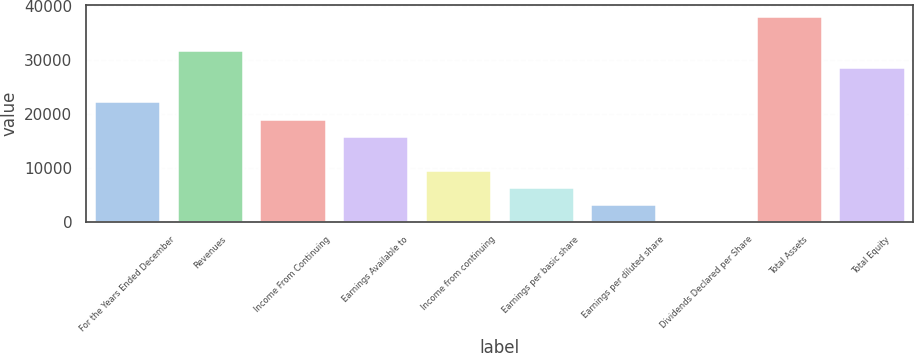Convert chart. <chart><loc_0><loc_0><loc_500><loc_500><bar_chart><fcel>For the Years Ended December<fcel>Revenues<fcel>Income From Continuing<fcel>Earnings Available to<fcel>Income from continuing<fcel>Earnings per basic share<fcel>Earnings per diluted share<fcel>Dividends Declared per Share<fcel>Total Assets<fcel>Total Equity<nl><fcel>22289.2<fcel>31841<fcel>19105.3<fcel>15921.4<fcel>9553.5<fcel>6369.57<fcel>3185.64<fcel>1.71<fcel>38208.9<fcel>28657.1<nl></chart> 